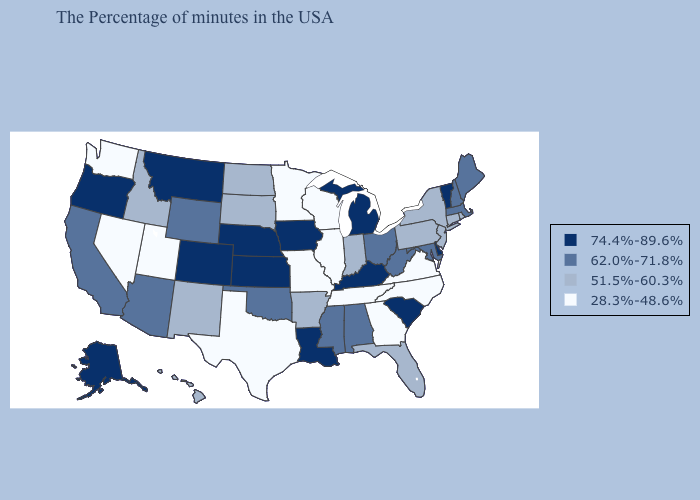Is the legend a continuous bar?
Write a very short answer. No. Name the states that have a value in the range 74.4%-89.6%?
Write a very short answer. Vermont, Delaware, South Carolina, Michigan, Kentucky, Louisiana, Iowa, Kansas, Nebraska, Colorado, Montana, Oregon, Alaska. What is the value of Illinois?
Be succinct. 28.3%-48.6%. What is the lowest value in states that border Missouri?
Answer briefly. 28.3%-48.6%. Does Kentucky have a higher value than Tennessee?
Quick response, please. Yes. Does Washington have the lowest value in the USA?
Keep it brief. Yes. Among the states that border Ohio , does West Virginia have the lowest value?
Answer briefly. No. Among the states that border Idaho , which have the highest value?
Keep it brief. Montana, Oregon. Name the states that have a value in the range 74.4%-89.6%?
Give a very brief answer. Vermont, Delaware, South Carolina, Michigan, Kentucky, Louisiana, Iowa, Kansas, Nebraska, Colorado, Montana, Oregon, Alaska. What is the lowest value in the Northeast?
Keep it brief. 51.5%-60.3%. Name the states that have a value in the range 62.0%-71.8%?
Keep it brief. Maine, Massachusetts, New Hampshire, Maryland, West Virginia, Ohio, Alabama, Mississippi, Oklahoma, Wyoming, Arizona, California. Name the states that have a value in the range 74.4%-89.6%?
Quick response, please. Vermont, Delaware, South Carolina, Michigan, Kentucky, Louisiana, Iowa, Kansas, Nebraska, Colorado, Montana, Oregon, Alaska. What is the lowest value in the Northeast?
Give a very brief answer. 51.5%-60.3%. What is the value of Michigan?
Be succinct. 74.4%-89.6%. Does Vermont have the highest value in the Northeast?
Answer briefly. Yes. 